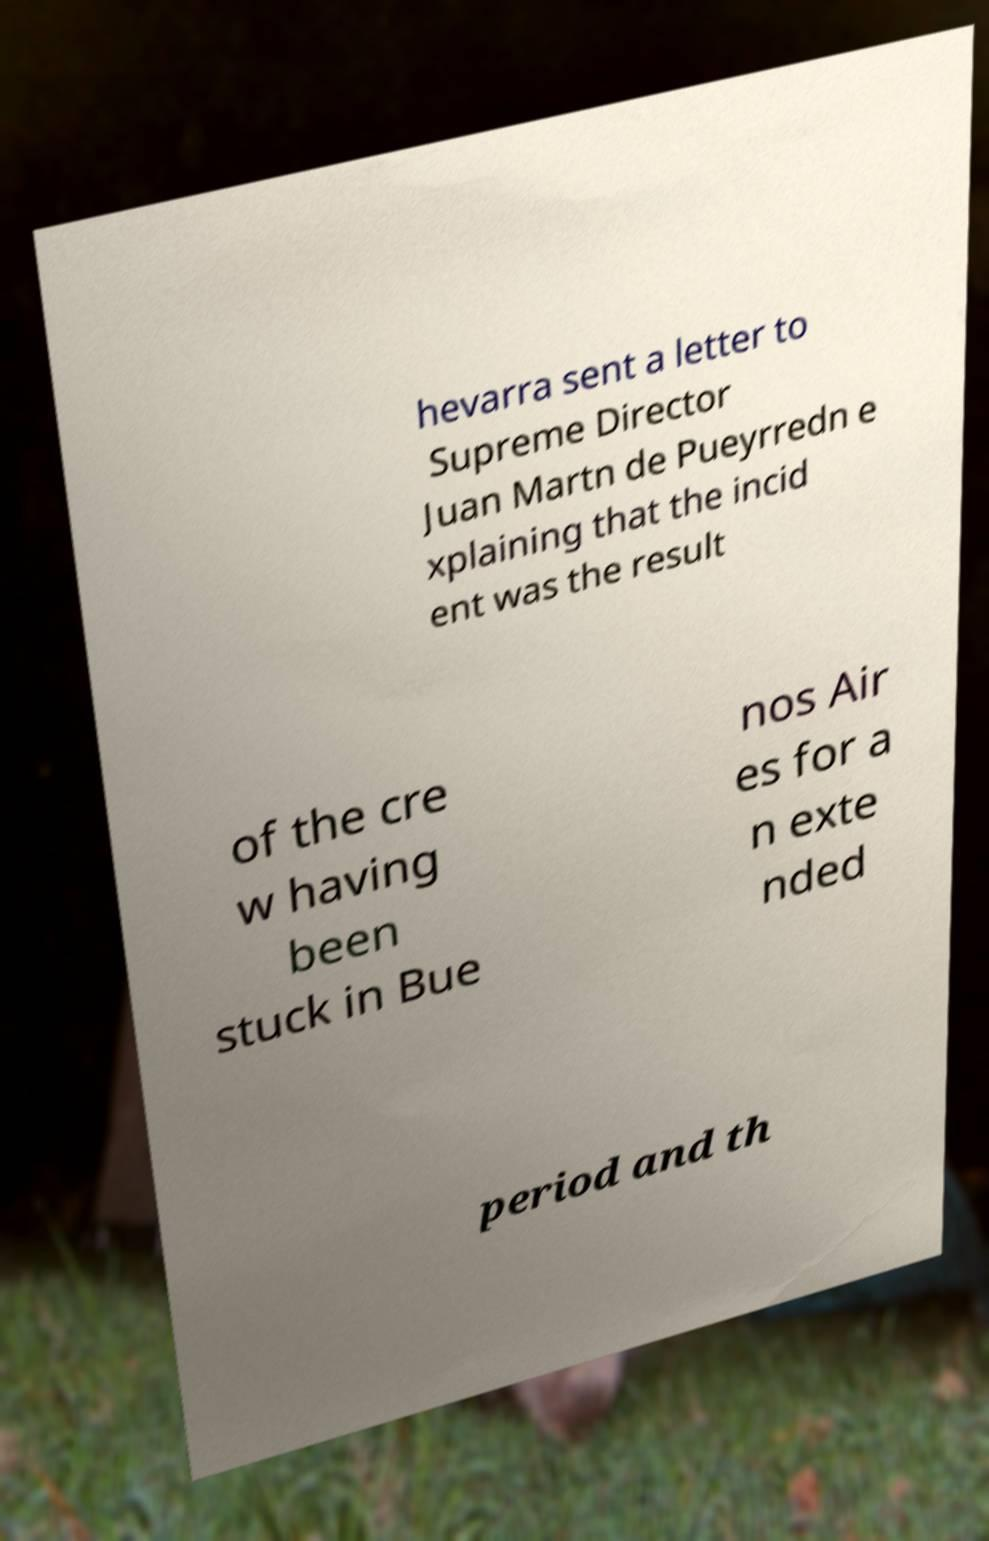Please read and relay the text visible in this image. What does it say? hevarra sent a letter to Supreme Director Juan Martn de Pueyrredn e xplaining that the incid ent was the result of the cre w having been stuck in Bue nos Air es for a n exte nded period and th 